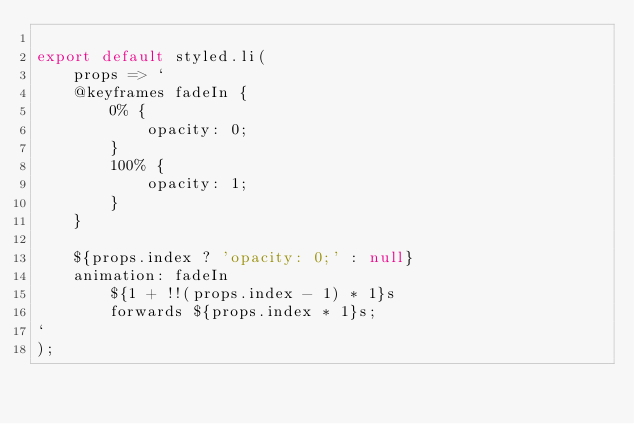<code> <loc_0><loc_0><loc_500><loc_500><_JavaScript_>
export default styled.li(
    props => `
    @keyframes fadeIn {
        0% {
            opacity: 0;
        }
        100% {
            opacity: 1;
        }
    }

    ${props.index ? 'opacity: 0;' : null}
    animation: fadeIn
        ${1 + !!(props.index - 1) * 1}s
        forwards ${props.index * 1}s;
`
);
</code> 